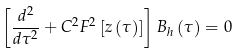<formula> <loc_0><loc_0><loc_500><loc_500>\left [ \frac { d ^ { 2 } } { d \tau ^ { 2 } } + C ^ { 2 } F ^ { 2 } \left [ z \left ( \tau \right ) \right ] \right ] B _ { h } \left ( \tau \right ) = 0</formula> 